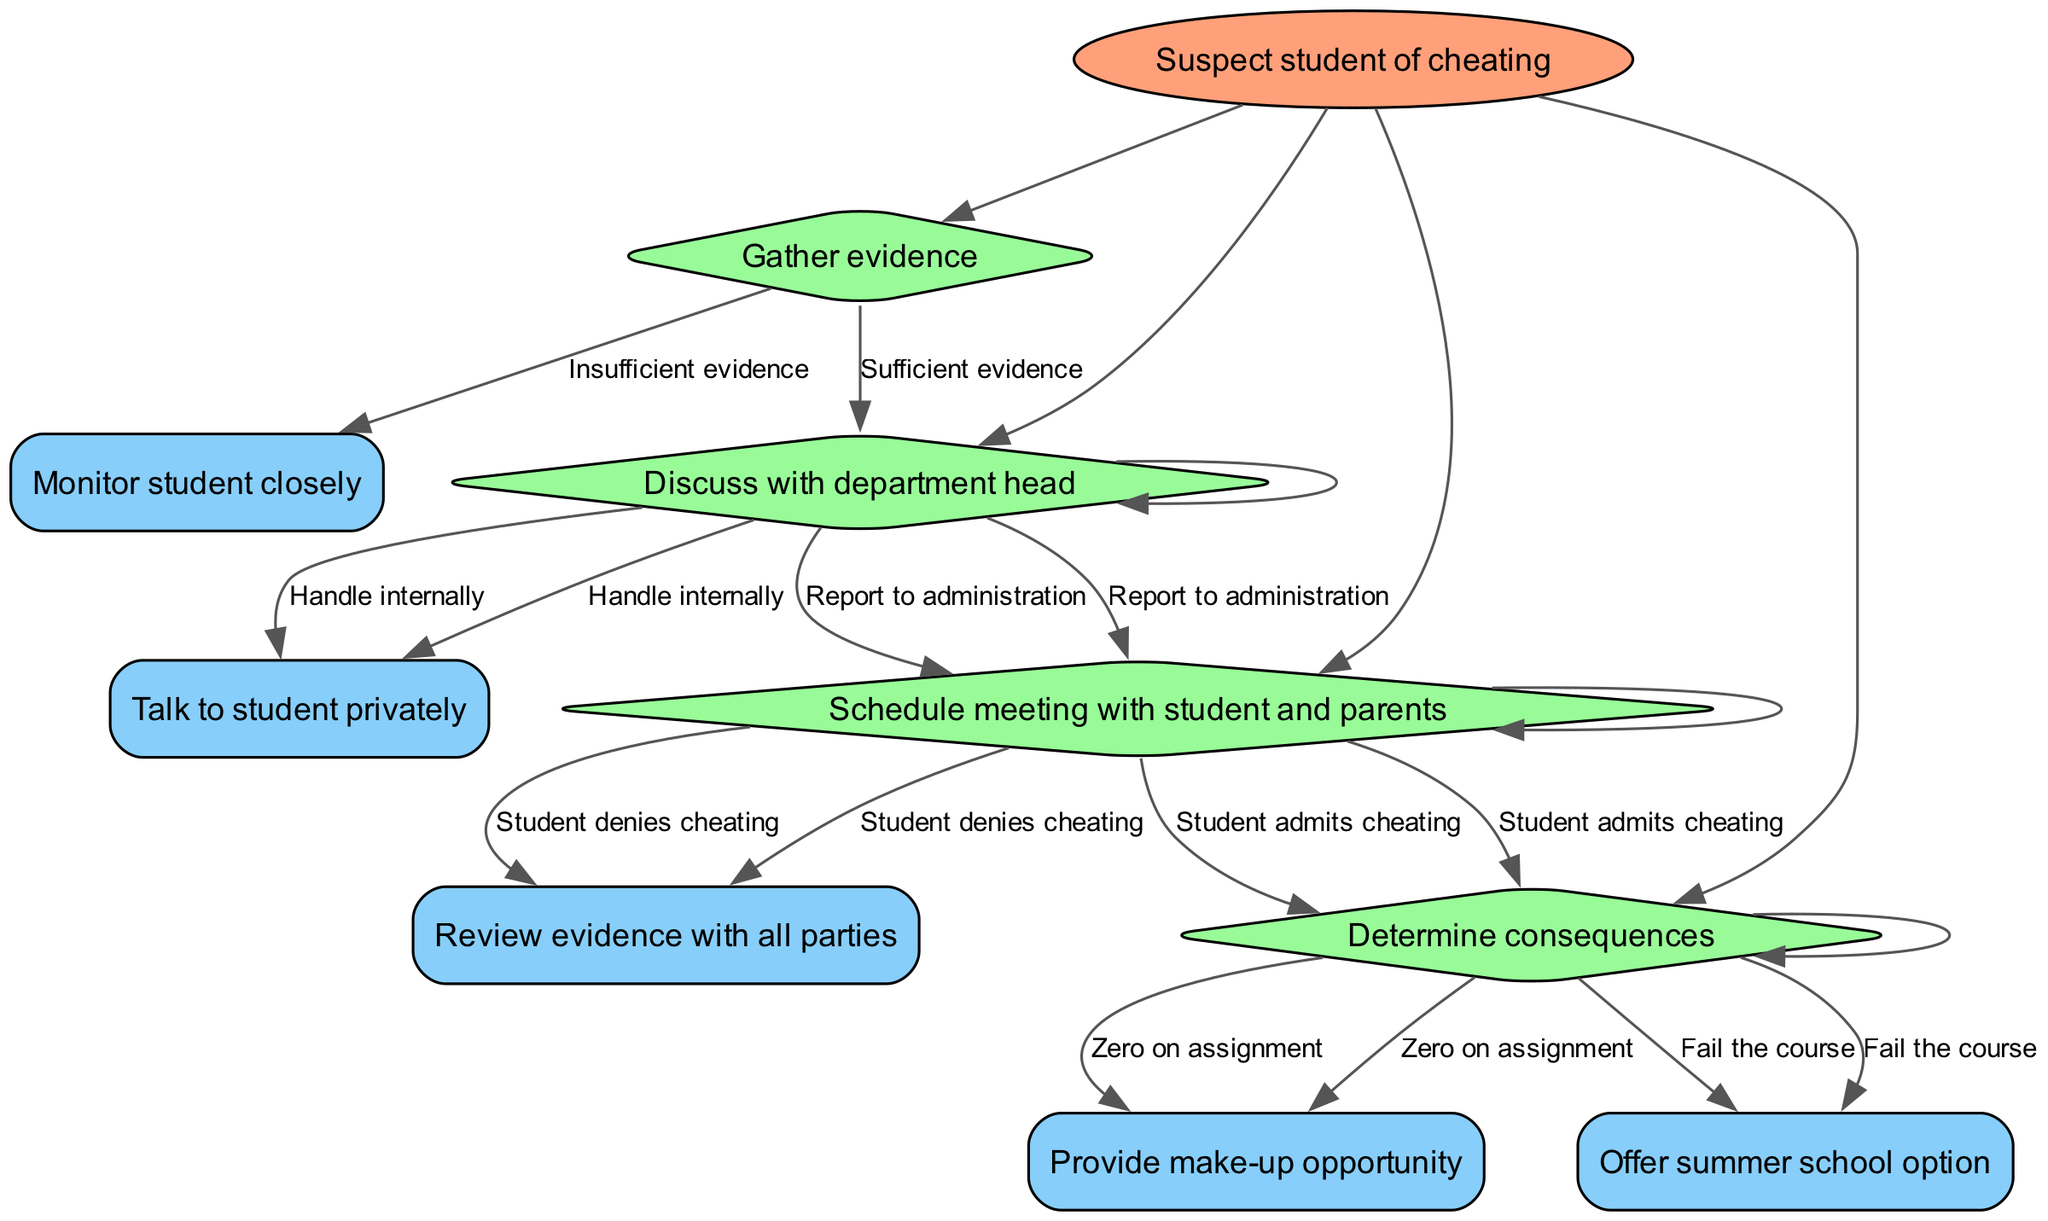What is the root decision in this diagram? The root decision is indicated at the top of the diagram, which states "Suspect student of cheating." This is the initial point that leads to further decisions based on the situation.
Answer: Suspect student of cheating How many options does the "Gather evidence" node have? The "Gather evidence" node has two options listed below it: "Sufficient evidence" and "Insufficient evidence." Both choices lead to different subsequent actions.
Answer: 2 What is the next action after "Student denies cheating"? After "Student denies cheating," the next action indicated is "Review evidence with all parties." This step involves further discussion after the denial of cheating has been made.
Answer: Review evidence with all parties What happens if there is "Insufficient evidence"? If there is "Insufficient evidence," the procedure directs to "Monitor student closely." This indicates a more cautious approach when there isn't clear proof of cheating.
Answer: Monitor student closely What are the consequences if the student admits to cheating? If the student admits to cheating, the next step is "Determine consequences," which implies there will be a discussion about what happens next after the admission.
Answer: Determine consequences What are the two choices under "Determine consequences"? The two choices listed under "Determine consequences" are "Zero on assignment" and "Fail the course." Each option leads to a different outcome regarding the student's overall performance.
Answer: Zero on assignment, Fail the course What action follows after "Report to administration"? After "Report to administration," the next action is to "Schedule meeting with student and parents." This indicates a formal step to involve more parties in the situation.
Answer: Schedule meeting with student and parents What does the "Discuss with department head" node connect to? The "Discuss with department head" node connects to two options: "Report to administration" and "Handle internally." Each of these options leads to further consequences regarding how the situation is dealt with.
Answer: Report to administration, Handle internally What is the first node after the root? The first node directly below the root decision is "Gather evidence." This is the action to be taken immediately after suspecting a student of cheating.
Answer: Gather evidence 